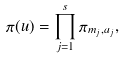Convert formula to latex. <formula><loc_0><loc_0><loc_500><loc_500>\pi ( u ) = \prod _ { j = 1 } ^ { s } \pi _ { m _ { j } , a _ { j } } ,</formula> 